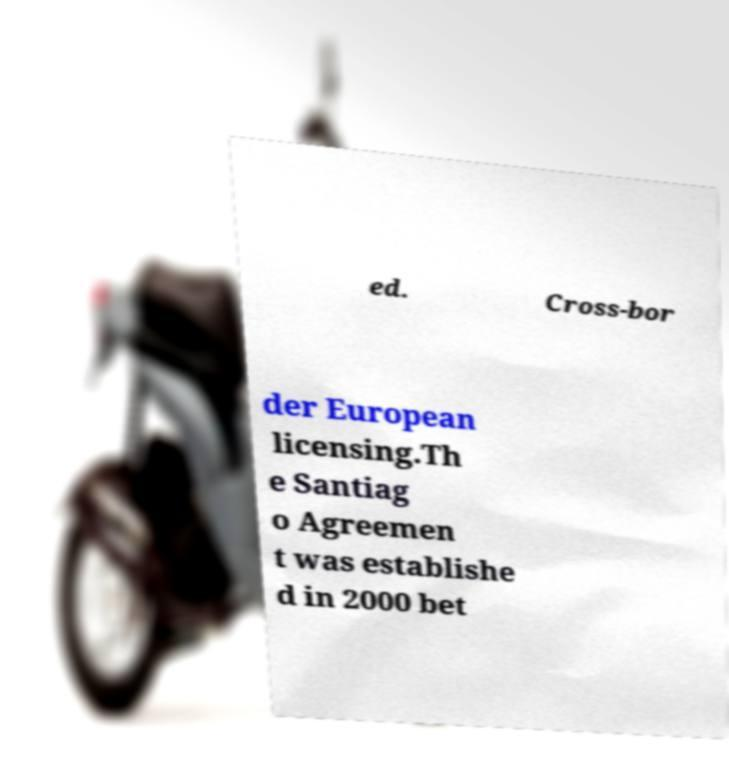What messages or text are displayed in this image? I need them in a readable, typed format. ed. Cross-bor der European licensing.Th e Santiag o Agreemen t was establishe d in 2000 bet 